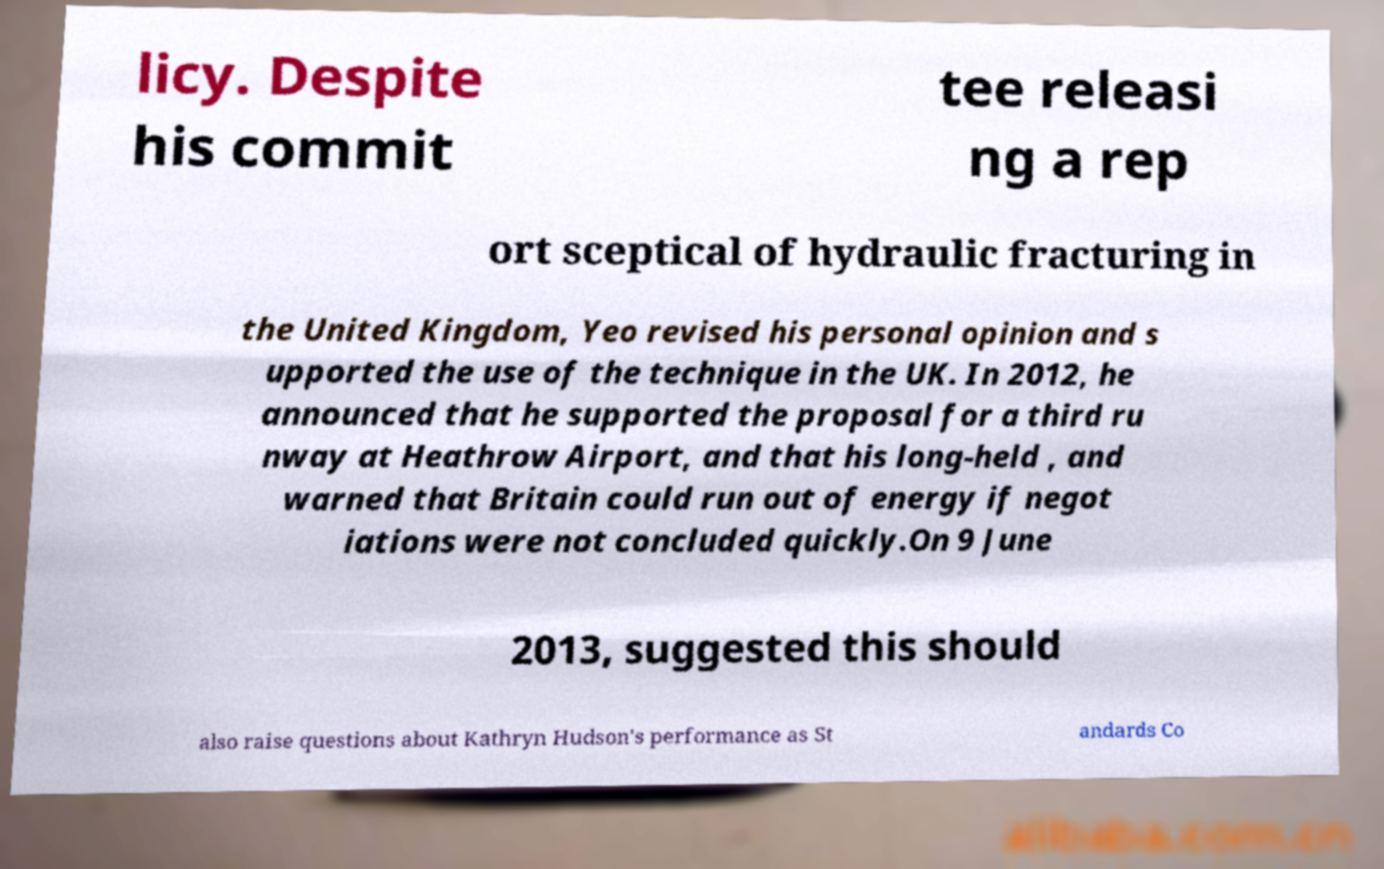For documentation purposes, I need the text within this image transcribed. Could you provide that? licy. Despite his commit tee releasi ng a rep ort sceptical of hydraulic fracturing in the United Kingdom, Yeo revised his personal opinion and s upported the use of the technique in the UK. In 2012, he announced that he supported the proposal for a third ru nway at Heathrow Airport, and that his long-held , and warned that Britain could run out of energy if negot iations were not concluded quickly.On 9 June 2013, suggested this should also raise questions about Kathryn Hudson's performance as St andards Co 